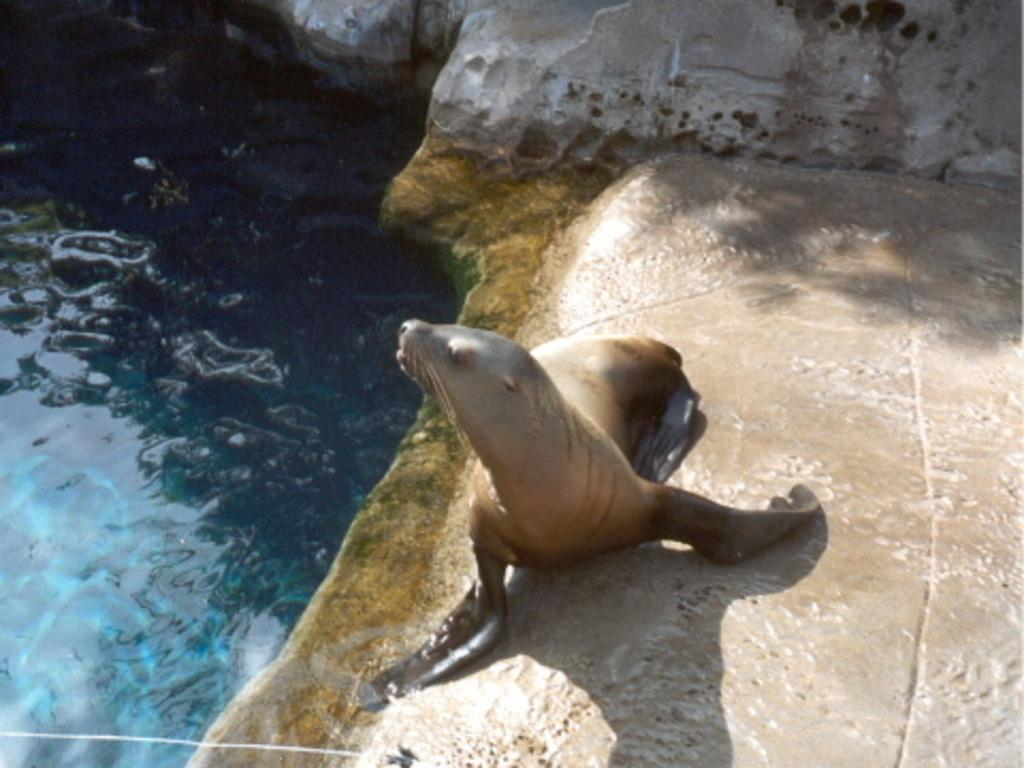Where was the picture taken? The picture was clicked outside. What animal can be seen on the ground in the image? There is a sea lion on the ground in the image. What is located on the left side of the image? There is a water body on the left side of the image. What can be seen in the background of the image? Rocks are visible in the background of the image. What type of ear is visible on the sea lion in the image? There are no visible ears on the sea lion in the image, as sea lions have small, inconspicuous ears. What organization is responsible for the maintenance of the water body in the image? The image does not provide information about any organizations responsible for the maintenance of the water body. 